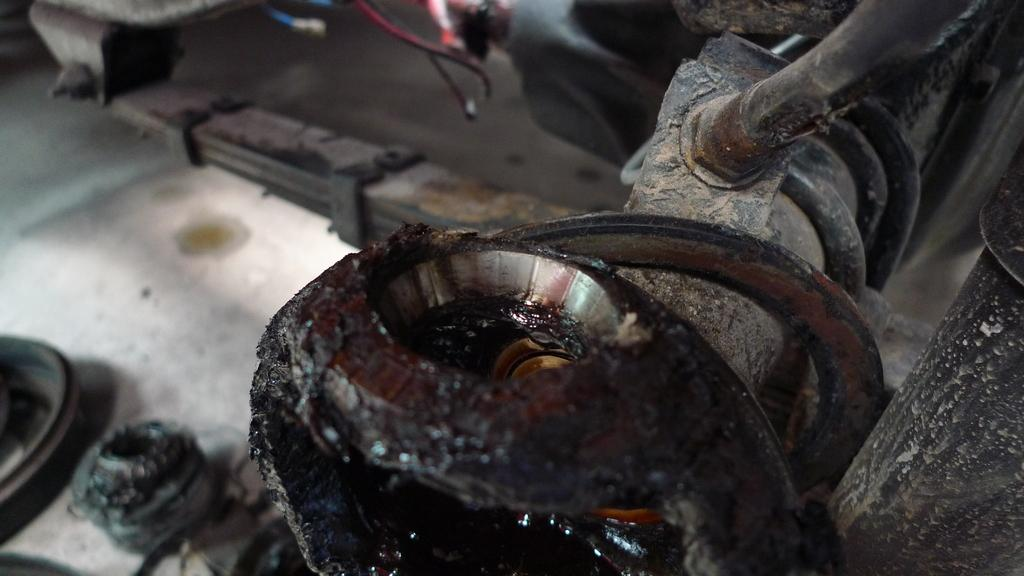What part of a vehicle is visible in the image? The image contains the under part of a vehicle. Which direction is the vehicle moving in the image? The image does not show the vehicle moving, nor does it provide any information about the direction of movement. What type of plate is attached to the under part of the vehicle in the image? There is no plate visible on the under part of the vehicle in the image. What type of disease can be seen affecting the under part of the vehicle in the image? There is no disease present on the under part of the vehicle in the image. 